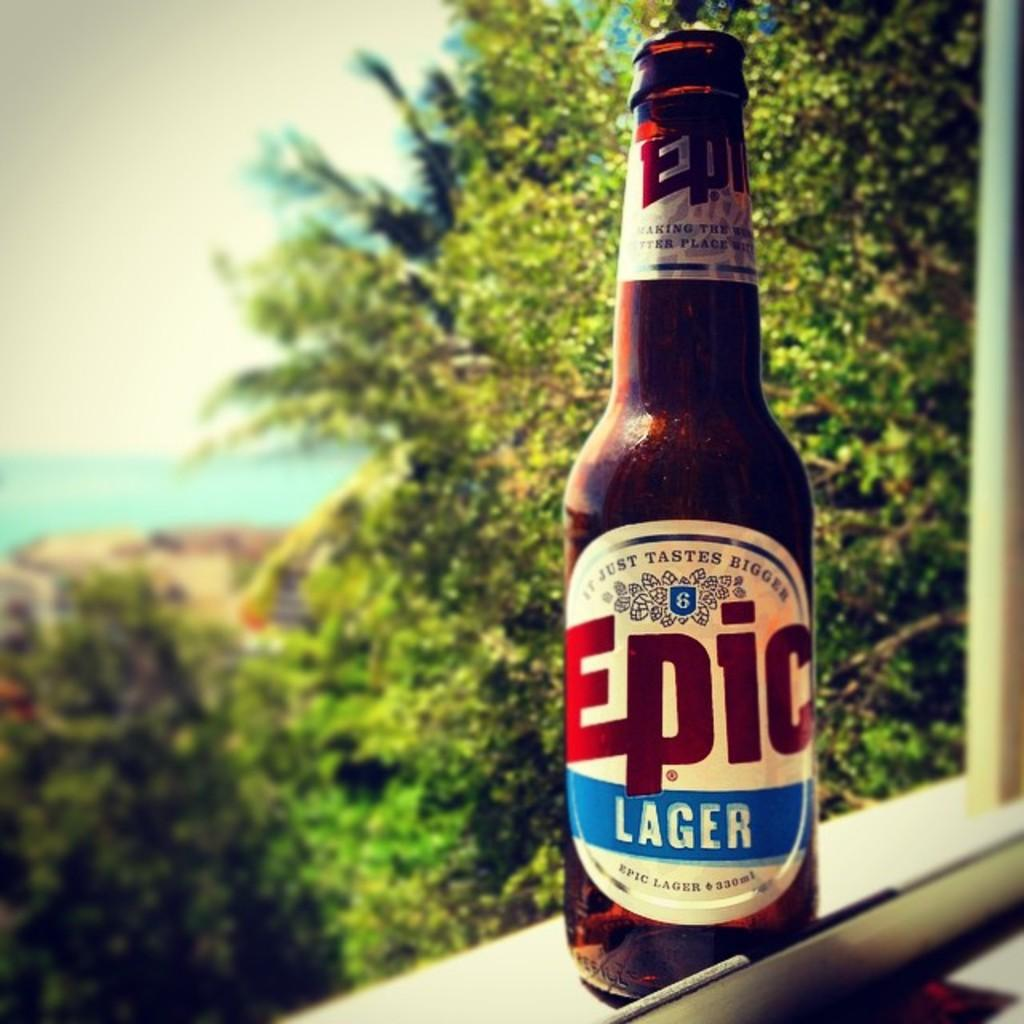<image>
Write a terse but informative summary of the picture. A bottle of Epic Lager resting in a window cell on a sunny day. 